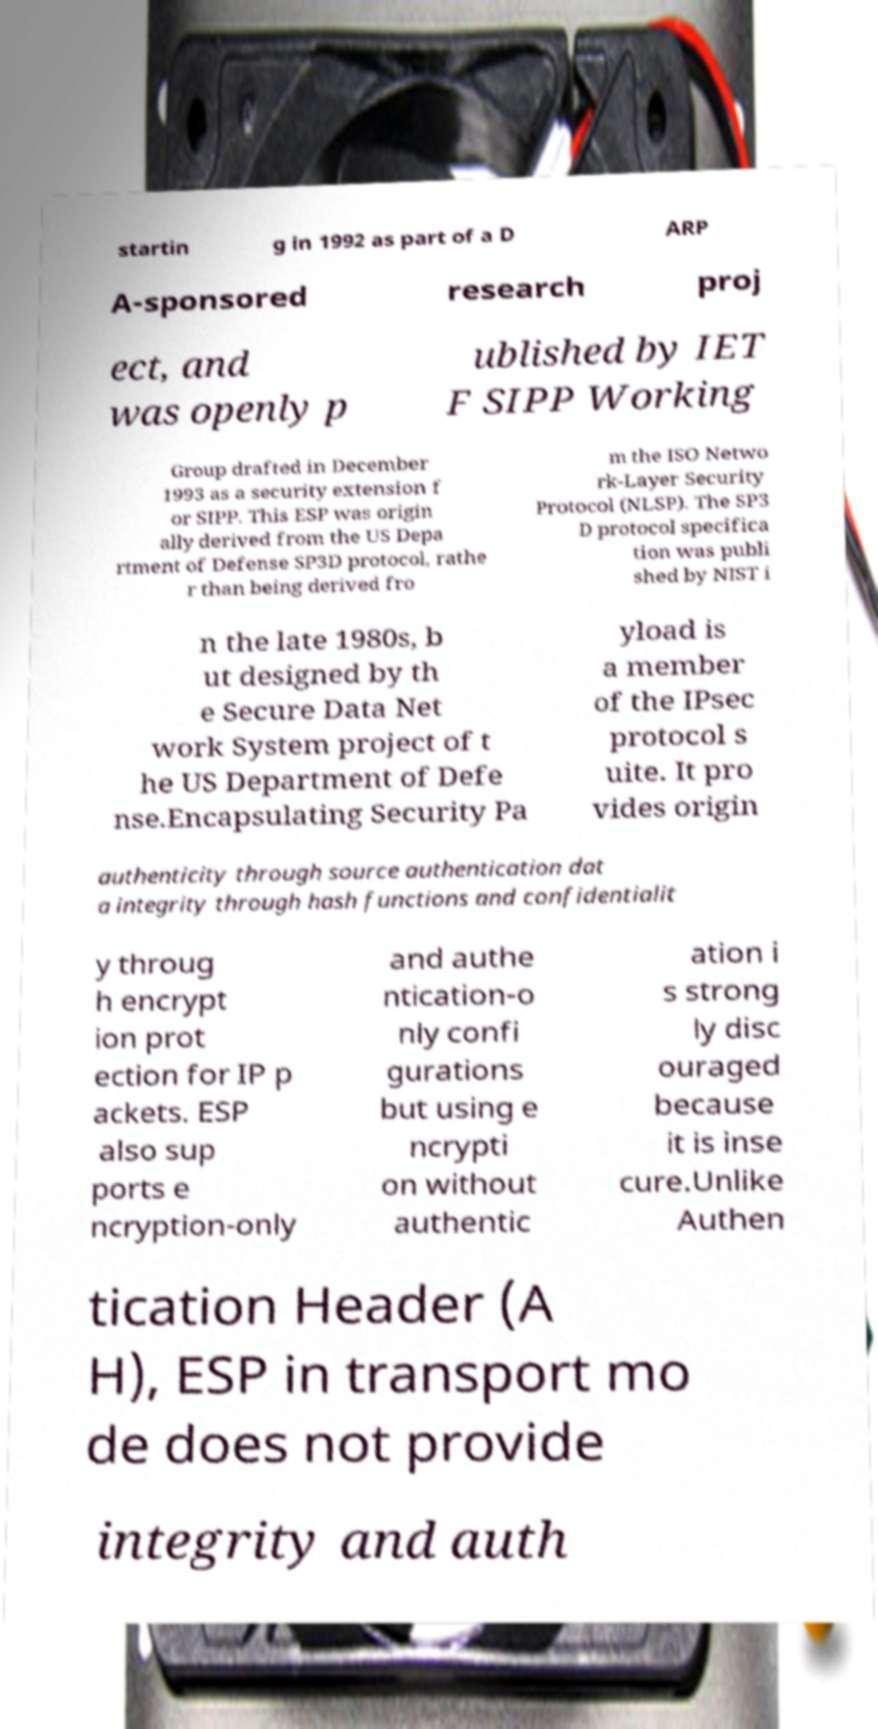Could you assist in decoding the text presented in this image and type it out clearly? startin g in 1992 as part of a D ARP A-sponsored research proj ect, and was openly p ublished by IET F SIPP Working Group drafted in December 1993 as a security extension f or SIPP. This ESP was origin ally derived from the US Depa rtment of Defense SP3D protocol, rathe r than being derived fro m the ISO Netwo rk-Layer Security Protocol (NLSP). The SP3 D protocol specifica tion was publi shed by NIST i n the late 1980s, b ut designed by th e Secure Data Net work System project of t he US Department of Defe nse.Encapsulating Security Pa yload is a member of the IPsec protocol s uite. It pro vides origin authenticity through source authentication dat a integrity through hash functions and confidentialit y throug h encrypt ion prot ection for IP p ackets. ESP also sup ports e ncryption-only and authe ntication-o nly confi gurations but using e ncrypti on without authentic ation i s strong ly disc ouraged because it is inse cure.Unlike Authen tication Header (A H), ESP in transport mo de does not provide integrity and auth 